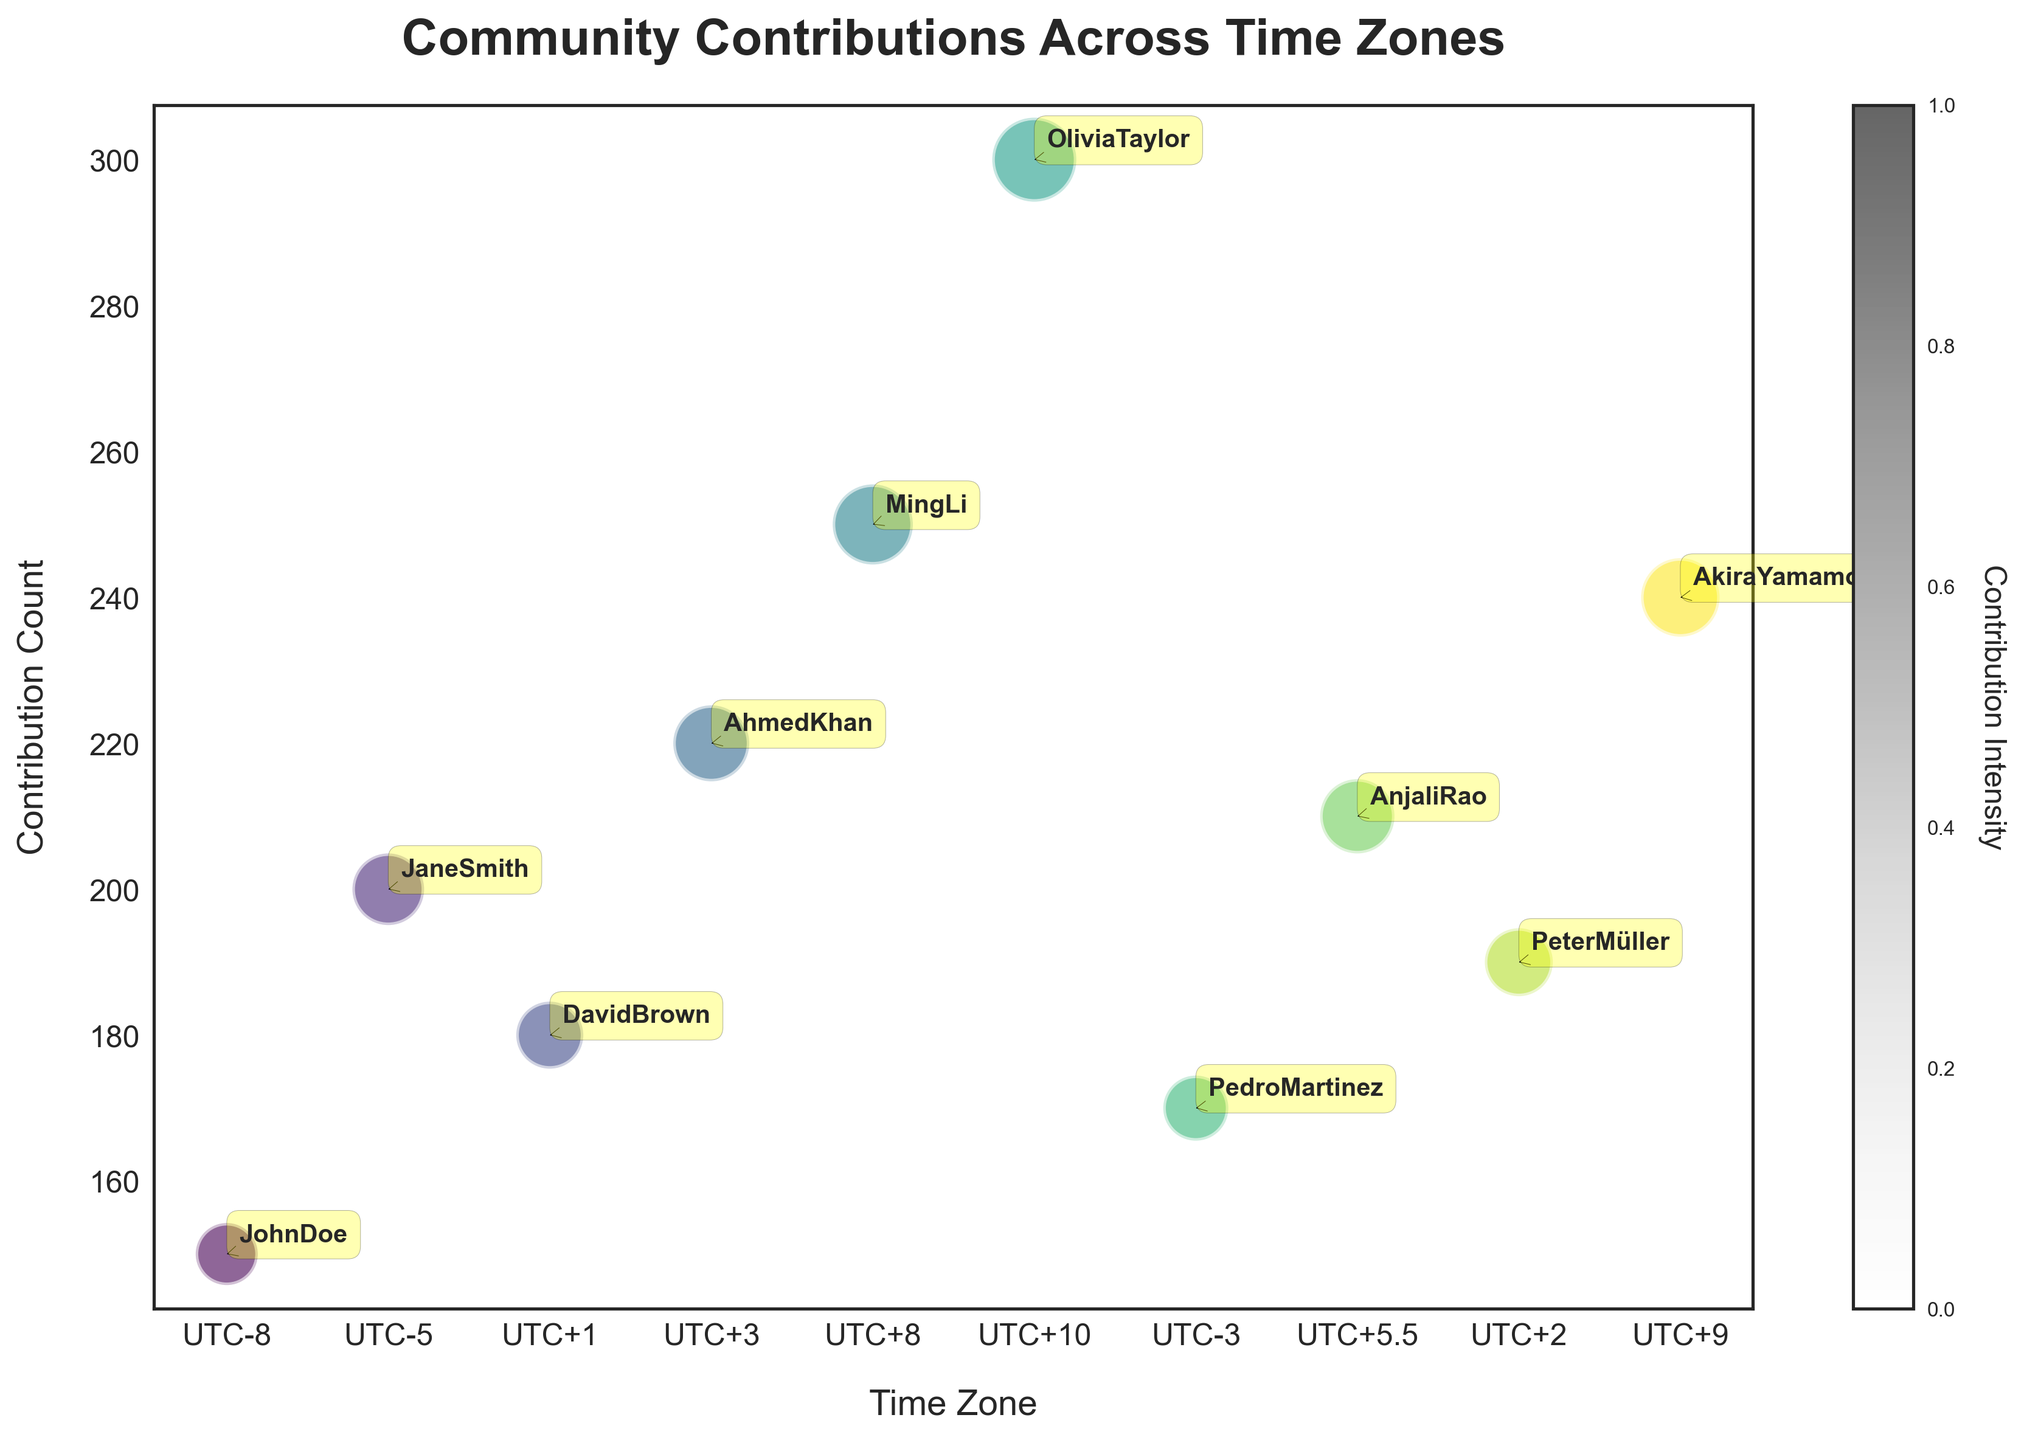what is the title of the figure? The figure's title appears at the top and reads 'Community Contributions Across Time Zones'.
Answer: Community Contributions Across Time Zones What does the y-axis represent? The y-axis label, placed vertically along the left side of the plot, shows that the y-axis represents the 'Contribution Count'.
Answer: Contribution Count How many data points are shown in the figure? By counting each unique bubble and their associated labels on the plot, we can determine that there are 10 data points.
Answer: 10 Which time zone has the highest Contribution Count? The bubble located at the highest point on the y-axis represents the highest Contribution Count, which corresponds to "UTC+10" for Olivia Taylor.
Answer: UTC+10 What is the range of Bubble Sizes in the figure? By inspecting the size of the bubbles, we can identify that the smallest bubble has a size of 30 and the largest bubble has a size of 55.
Answer: 30 to 55 What is the average Contribution Count for all time zones? First, sum the Contribution Counts (150 + 200 + 180 + 220 + 250 + 300 + 170 + 210 + 190 + 240 = 2110). Then, divide by the number of data points (2110 / 10 = 211).
Answer: 211 Which contributors have Contribution Counts greater than 200? By examining the y-axis and the bubbles placed above the 200 mark, we find that AhmedKhan, MingLi, OliviaTaylor, AnjaliRao, and AkiraYamamoto have Contribution Counts greater than 200.
Answer: AhmedKhan, MingLi, OliviaTaylor, AnjaliRao, AkiraYamamoto How does the Contribution Count of UTC+1 compare with UTC-3? Comparing the y-axis positions of the corresponding bubbles, UTC+1 (DavidBrown) has a Contribution Count of 180, while UTC-3 (PedroMartinez) has 170. UTC+1 is 10 units more.
Answer: UTC+1 > UTC-3 Which time zone has the largest bubble and what is its size? The largest bubble can be identified visually as the most prominent one on the plot, which corresponds to UTC+10. Its Bubble Size is 55.
Answer: UTC+10, 55 What are the respective Contribution Counts of the contributors in UTC+2 and UTC+3? Checking the y-axis positions for the respective contributors, PeterMüller in UTC+2 has a Contribution Count of 190, and AhmedKhan in UTC+3 has 220.
Answer: UTC+2: 190, UTC+3: 220 